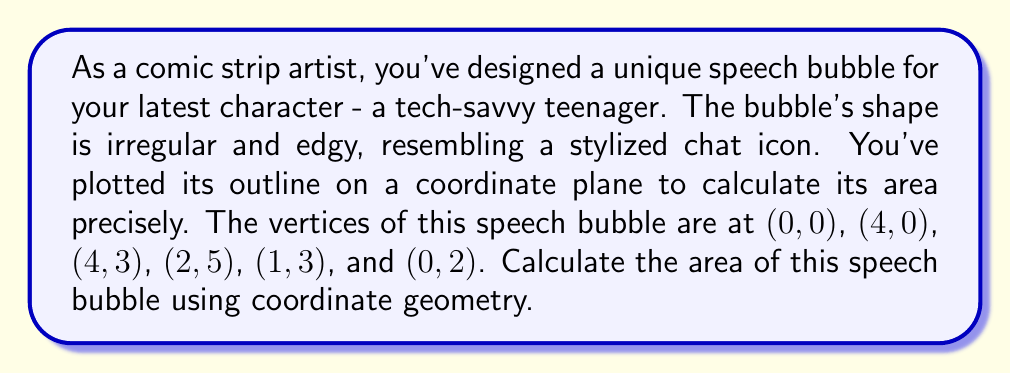Teach me how to tackle this problem. To find the area of this irregular shape, we can use the Shoelace formula (also known as the surveyor's formula). This method calculates the area of a polygon given the coordinates of its vertices.

The formula is:

$$ A = \frac{1}{2}|\sum_{i=1}^{n-1} (x_iy_{i+1} - x_{i+1}y_i) + (x_ny_1 - x_1y_n)| $$

Where $(x_i, y_i)$ are the coordinates of the $i$-th vertex.

Let's apply this to our speech bubble:

1) First, let's list our vertices in order:
   (0,0), (4,0), (4,3), (2,5), (1,3), (0,2)

2) Now, let's calculate each term in the sum:

   $(0 \cdot 0) - (4 \cdot 0) = 0$
   $(4 \cdot 3) - (4 \cdot 0) = 12$
   $(4 \cdot 5) - (2 \cdot 3) = 14$
   $(2 \cdot 3) - (1 \cdot 5) = 1$
   $(1 \cdot 2) - (0 \cdot 3) = 2$
   $(0 \cdot 0) - (0 \cdot 2) = 0$

3) Sum these values:
   $0 + 12 + 14 + 1 + 2 + 0 = 29$

4) Multiply by 1/2:
   $\frac{1}{2} \cdot 29 = 14.5$

Therefore, the area of the speech bubble is 14.5 square units.

[asy]
unitsize(1cm);
draw((0,0)--(4,0)--(4,3)--(2,5)--(1,3)--(0,2)--cycle);
dot((0,0)); dot((4,0)); dot((4,3)); dot((2,5)); dot((1,3)); dot((0,2));
label("(0,0)", (0,0), SW);
label("(4,0)", (4,0), SE);
label("(4,3)", (4,3), E);
label("(2,5)", (2,5), N);
label("(1,3)", (1,3), W);
label("(0,2)", (0,2), W);
[/asy]
Answer: The area of the speech bubble is 14.5 square units. 